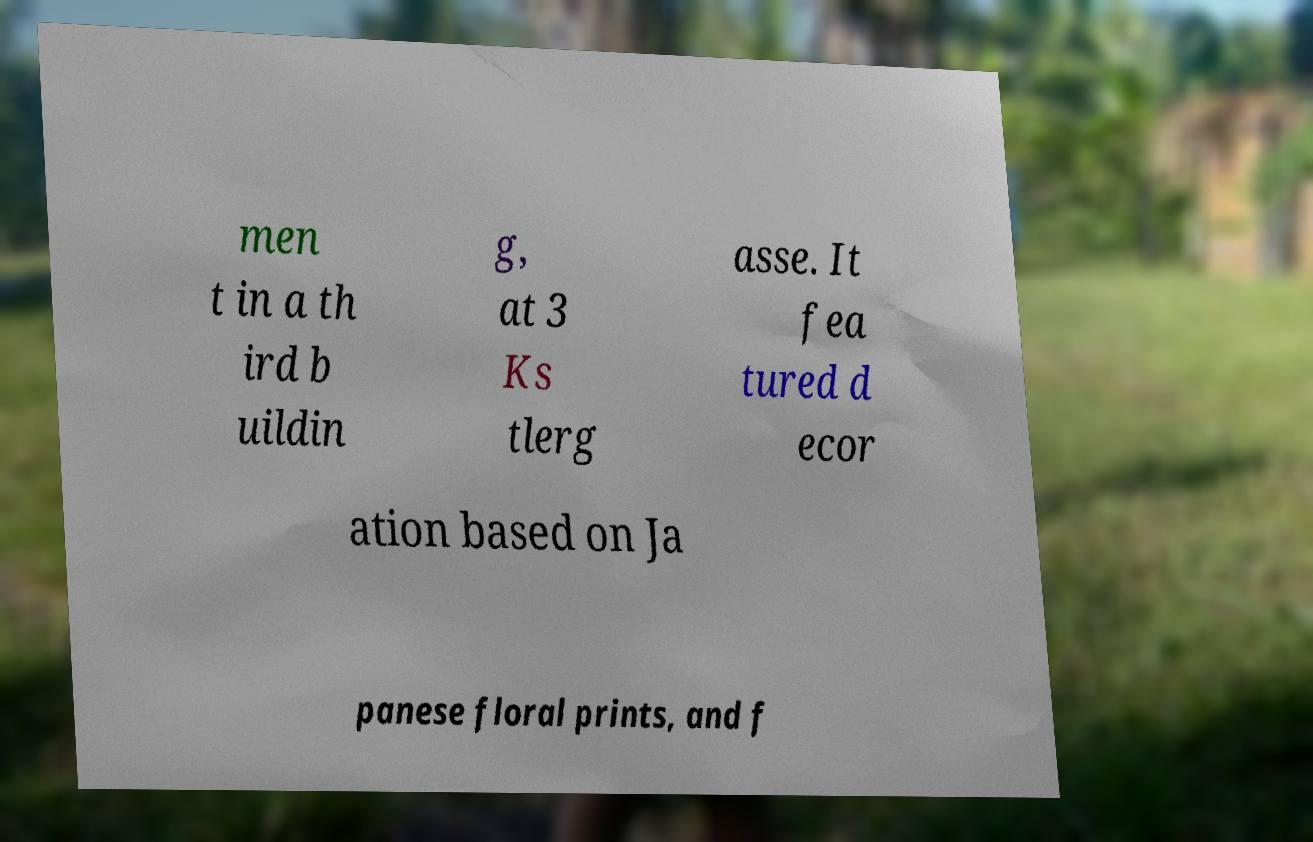Could you assist in decoding the text presented in this image and type it out clearly? men t in a th ird b uildin g, at 3 Ks tlerg asse. It fea tured d ecor ation based on Ja panese floral prints, and f 